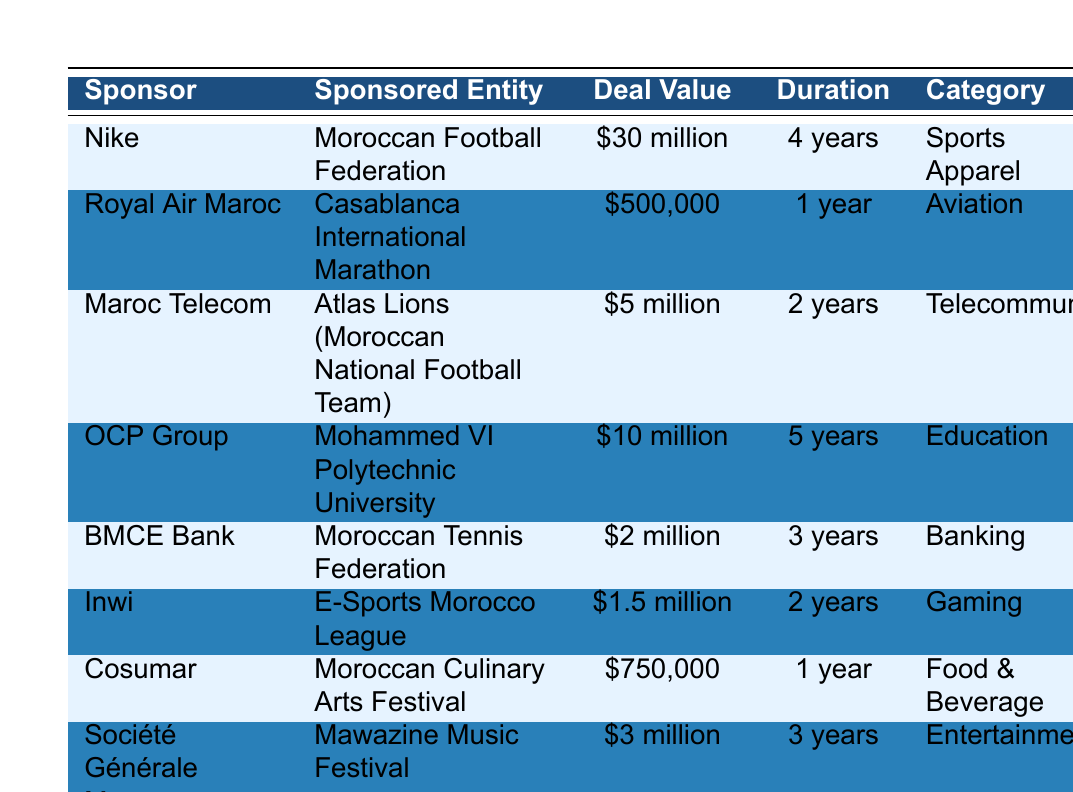What is the total deal value for all sponsorships listed in the table? To find the total deal value, we add all the individual deal values: $30 million + $500,000 + $5 million + $10 million + $2 million + $1.5 million + $750,000 + $3 million = $53.75 million.
Answer: $53.75 million Which sponsor has the longest duration for their sponsorship deal? The longest duration in the table is 5 years, which belongs to OCP Group for the deal with Mohammed VI Polytechnic University.
Answer: OCP Group Is the deal value of the sponsorship for the Casablanca International Marathon higher than $400,000? The deal value for the Casablanca International Marathon is $500,000, which is indeed higher than $400,000.
Answer: Yes How many sponsorship deals fall under the category of Entertainment? There's only one entry under the category of Entertainment, which is from Société Générale Maroc for the Mawazine Music Festival.
Answer: 1 What is the average deal value of all listed sponsorships? First, we convert each deal value to numbers: 30,000,000 + 500,000 + 5,000,000 + 10,000,000 + 2,000,000 + 1,500,000 + 750,000 + 3,000,000 = 53,750,000. Then, divide this by 8 (the number of deals) to find the average: 53,750,000 / 8 = 6,718,750.
Answer: $6.72 million Does Inwi sponsor an entity related to sports? Yes, Inwi sponsors the E-Sports Morocco League, which is a sports-related sponsorship in the gaming category.
Answer: Yes Which sponsor has the highest deal value and what is it? The highest deal value in the table belongs to Nike, with a deal value of $30 million for the Moroccan Football Federation.
Answer: Nike, $30 million What proportion of sponsorship deals last for 2 years? There are 2 deals that last for 2 years (Maroc Telecom and Inwi), out of a total of 8 deals. To find the proportion, we calculate 2/8 = 0.25, or 25%.
Answer: 25% Is there a sponsorship deal with a value less than $1 million? There is one sponsorship deal with a value less than $1 million, which is from Cosumar for the Moroccan Culinary Arts Festival at $750,000.
Answer: Yes 